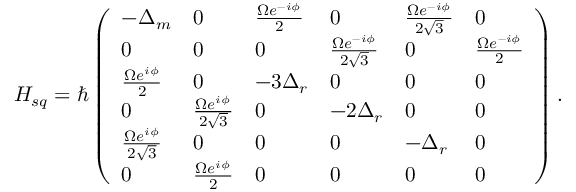Convert formula to latex. <formula><loc_0><loc_0><loc_500><loc_500>H _ { s q } = \hbar { \left } ( \begin{array} { l l l l l l } { - \Delta _ { m } } & { 0 } & { \frac { \Omega e ^ { - i \phi } } { 2 } } & { 0 } & { \frac { \Omega e ^ { - i \phi } } { 2 \sqrt { 3 } } } & { 0 } \\ { 0 } & { 0 } & { 0 } & { \frac { \Omega e ^ { - i \phi } } { 2 \sqrt { 3 } } } & { 0 } & { \frac { \Omega e ^ { - i \phi } } { 2 } } \\ { \frac { \Omega e ^ { i \phi } } { 2 } } & { 0 } & { - 3 \Delta _ { r } } & { 0 } & { 0 } & { 0 } \\ { 0 } & { \frac { \Omega e ^ { i \phi } } { 2 \sqrt { 3 } } } & { 0 } & { - 2 \Delta _ { r } } & { 0 } & { 0 } \\ { \frac { \Omega e ^ { i \phi } } { 2 \sqrt { 3 } } } & { 0 } & { 0 } & { 0 } & { - \Delta _ { r } } & { 0 } \\ { 0 } & { \frac { \Omega e ^ { i \phi } } { 2 } } & { 0 } & { 0 } & { 0 } & { 0 } \end{array} \right ) .</formula> 